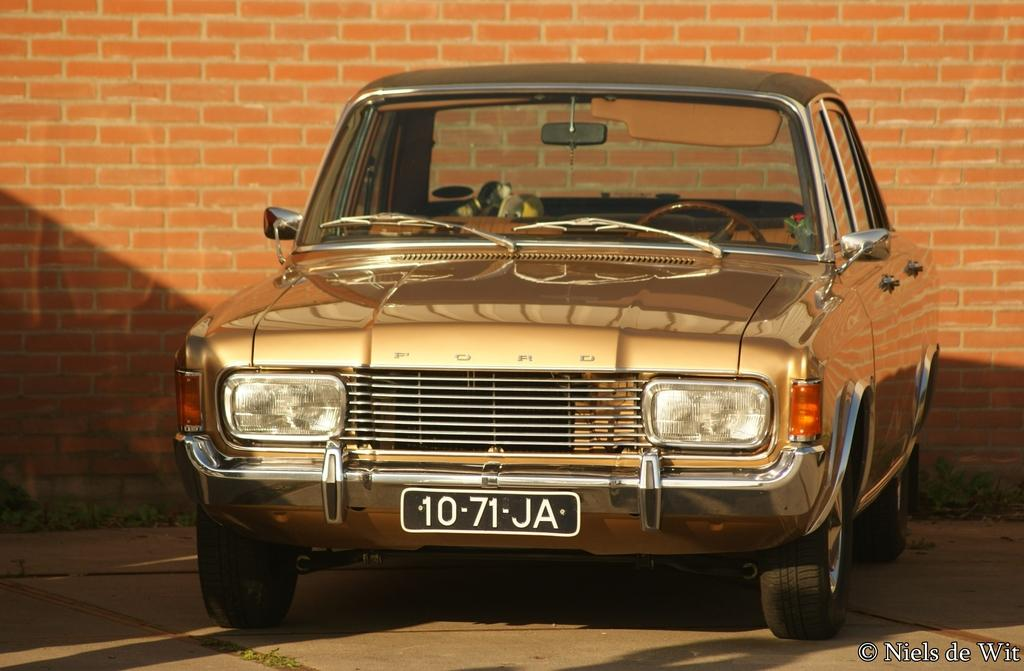What is the main subject of the image? There is a car in the image. Where is the car located in relation to other objects? The car is parked near a brick wall. What can be seen in the top right corner of the image? There is a watermark in the top right corner of the image. What type of vegetation is visible beside the car? There is grass visible beside the car. What type of lettuce is being served at the party in the image? There is no party or lettuce present in the image; it features a parked car near a brick wall with grass beside it. 